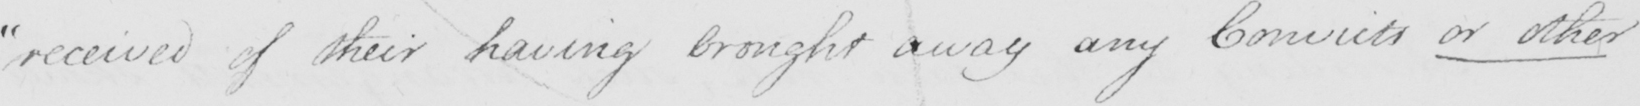Can you tell me what this handwritten text says? " received of their having brought away any Convicts or other 